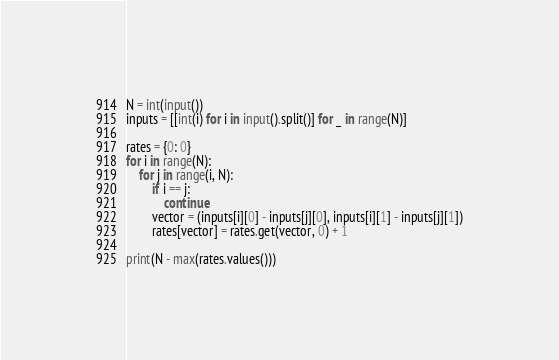Convert code to text. <code><loc_0><loc_0><loc_500><loc_500><_Python_>N = int(input())
inputs = [[int(i) for i in input().split()] for _ in range(N)]

rates = {0: 0}
for i in range(N):
    for j in range(i, N):
        if i == j:
            continue
        vector = (inputs[i][0] - inputs[j][0], inputs[i][1] - inputs[j][1])
        rates[vector] = rates.get(vector, 0) + 1

print(N - max(rates.values()))
</code> 